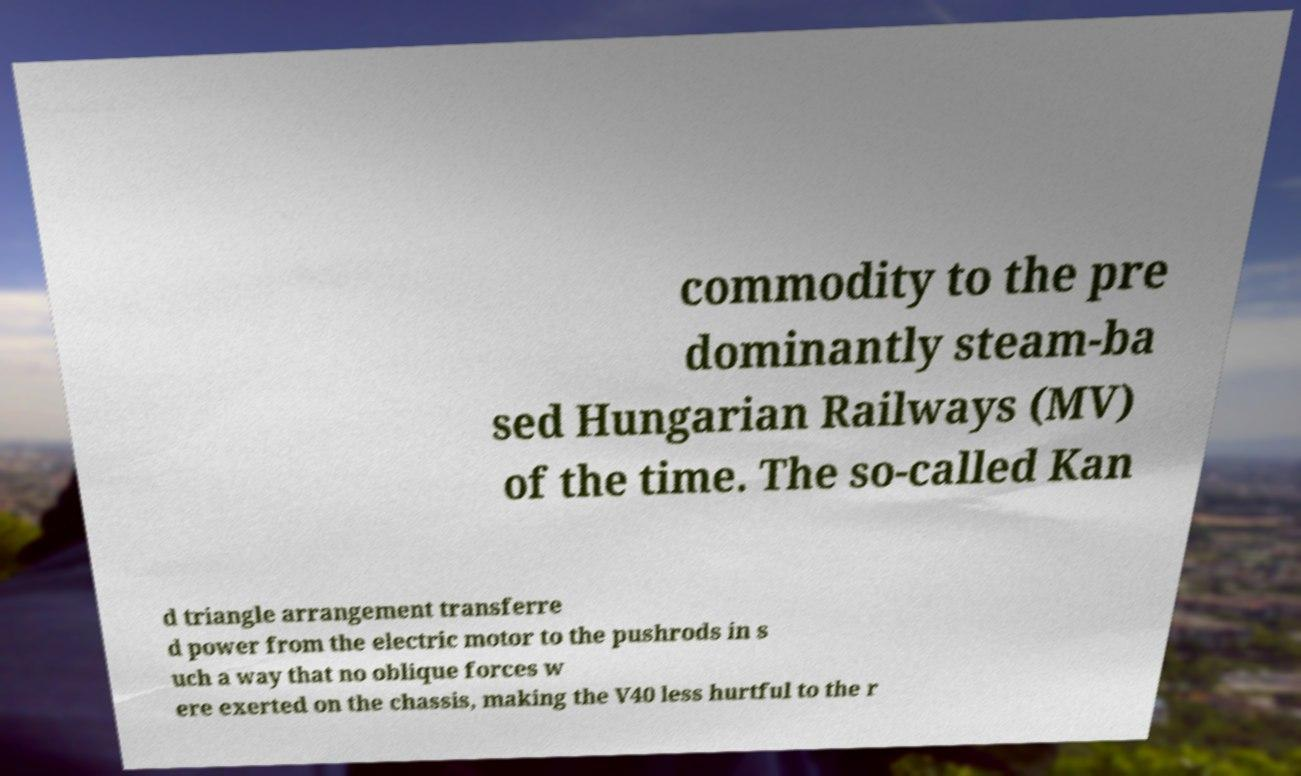Could you extract and type out the text from this image? commodity to the pre dominantly steam-ba sed Hungarian Railways (MV) of the time. The so-called Kan d triangle arrangement transferre d power from the electric motor to the pushrods in s uch a way that no oblique forces w ere exerted on the chassis, making the V40 less hurtful to the r 